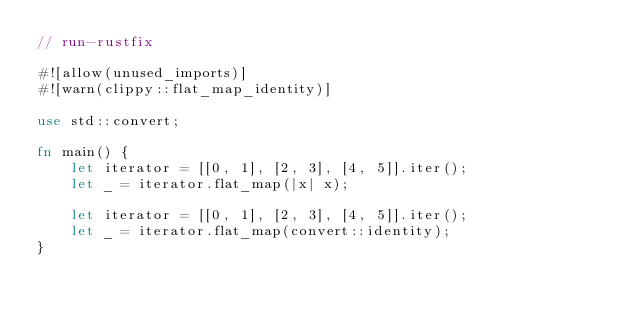<code> <loc_0><loc_0><loc_500><loc_500><_Rust_>// run-rustfix

#![allow(unused_imports)]
#![warn(clippy::flat_map_identity)]

use std::convert;

fn main() {
    let iterator = [[0, 1], [2, 3], [4, 5]].iter();
    let _ = iterator.flat_map(|x| x);

    let iterator = [[0, 1], [2, 3], [4, 5]].iter();
    let _ = iterator.flat_map(convert::identity);
}
</code> 